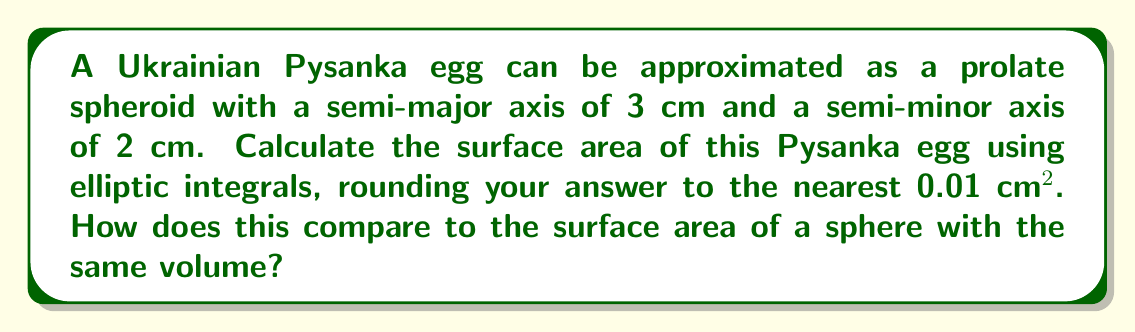Can you solve this math problem? Let's approach this step-by-step:

1) For a prolate spheroid with semi-major axis $a$ and semi-minor axis $b$, the surface area is given by:

   $$S = 2\pi b^2 + 2\pi \frac{ab}{\sqrt{a^2-b^2}} \sin^{-1}\left(\sqrt{\frac{a^2-b^2}{a^2}}\right)$$

2) In our case, $a = 3$ cm and $b = 2$ cm. Let's substitute these values:

   $$S = 2\pi (2)^2 + 2\pi \frac{3 \cdot 2}{\sqrt{3^2-2^2}} \sin^{-1}\left(\sqrt{\frac{3^2-2^2}{3^2}}\right)$$

3) Simplify:

   $$S = 8\pi + 12\pi \frac{1}{\sqrt{5}} \sin^{-1}\left(\sqrt{\frac{5}{9}}\right)$$

4) Calculate:

   $$S \approx 25.13 + 16.76 \cdot 0.7098 \approx 37.02 \text{ cm}^2$$

5) For comparison, let's calculate the volume of the spheroid:

   $$V = \frac{4}{3}\pi ab^2 = \frac{4}{3}\pi \cdot 3 \cdot 2^2 = \frac{16\pi}{3} \approx 16.76 \text{ cm}^3$$

6) A sphere with this volume would have radius:

   $$r = \sqrt[3]{\frac{3V}{4\pi}} \approx 1.59 \text{ cm}$$

7) The surface area of this sphere would be:

   $$S_{sphere} = 4\pi r^2 \approx 31.81 \text{ cm}^2$$

Thus, the Pysanka egg has a larger surface area than a sphere of the same volume.
Answer: 37.02 cm²; 5.21 cm² larger than equivalent sphere 